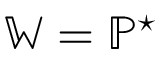<formula> <loc_0><loc_0><loc_500><loc_500>\mathbb { W } = \mathbb { P } ^ { ^ { * } }</formula> 